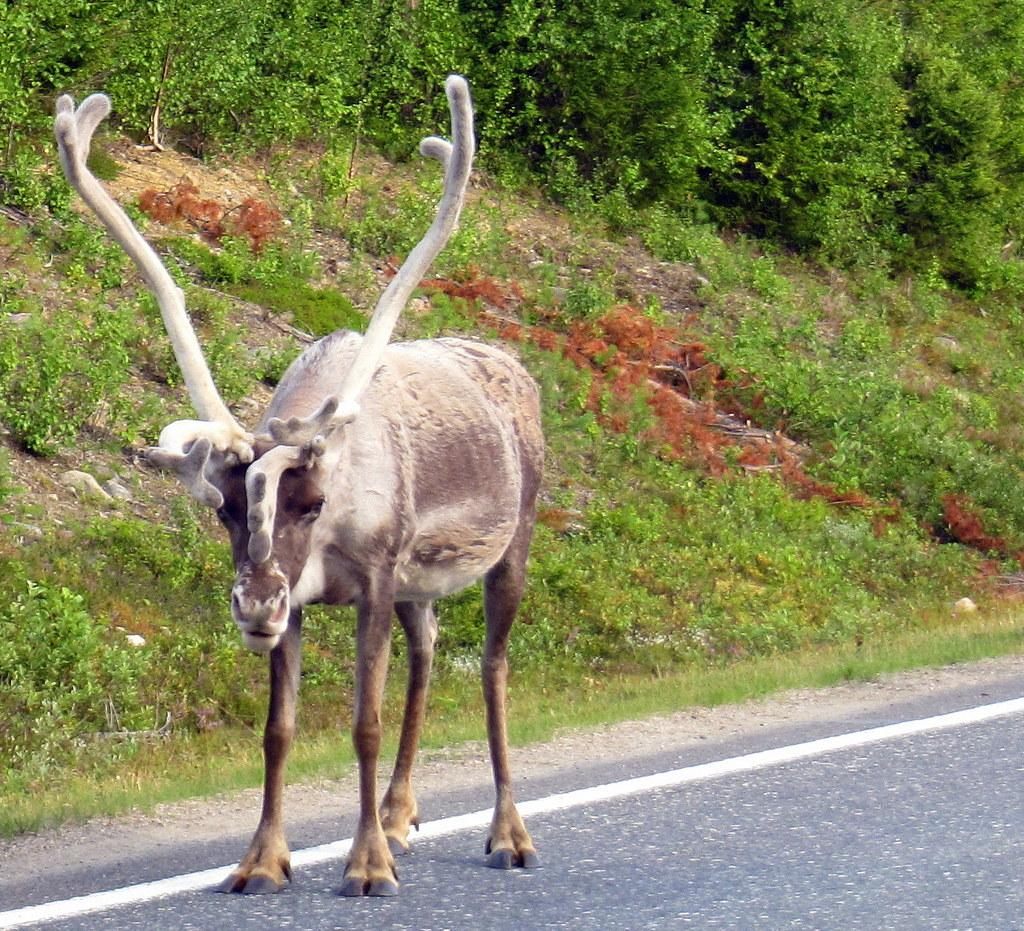Where was the image taken? The image was clicked outside. What can be seen in the foreground of the image? There is an animal standing on the ground in the foreground. What type of vegetation is visible in the background? There is green grass and plants in the background. What else can be seen in the background of the image? There are other items visible in the background. How many apples are hanging from the trees in the image? There are no apples visible in the image; only green grass, plants, and other unspecified items are present in the background. 